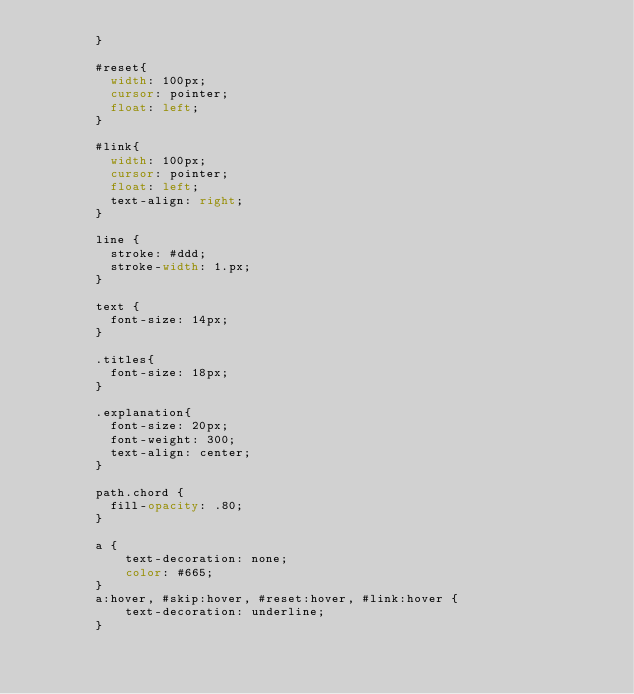Convert code to text. <code><loc_0><loc_0><loc_500><loc_500><_CSS_>		}
		
		#reset{
		  width: 100px;
		  cursor: pointer;	
		  float: left;			  
		}

		#link{
		  width: 100px;
		  cursor: pointer;	
		  float: left;	
		  text-align: right;
		}
		
		line {
		  stroke: #ddd;
		  stroke-width: 1.px;
		}

		text {
		  font-size: 14px;
		}

		.titles{
		  font-size: 18px;
		}

		.explanation{
		  font-size: 20px;
		  font-weight: 300;
		  text-align: center;
		}
		
		path.chord {
		  fill-opacity: .80;
		}
		
		a {
			text-decoration: none;
			color: #665;
		}
		a:hover, #skip:hover, #reset:hover, #link:hover {
			text-decoration: underline;
		}</code> 